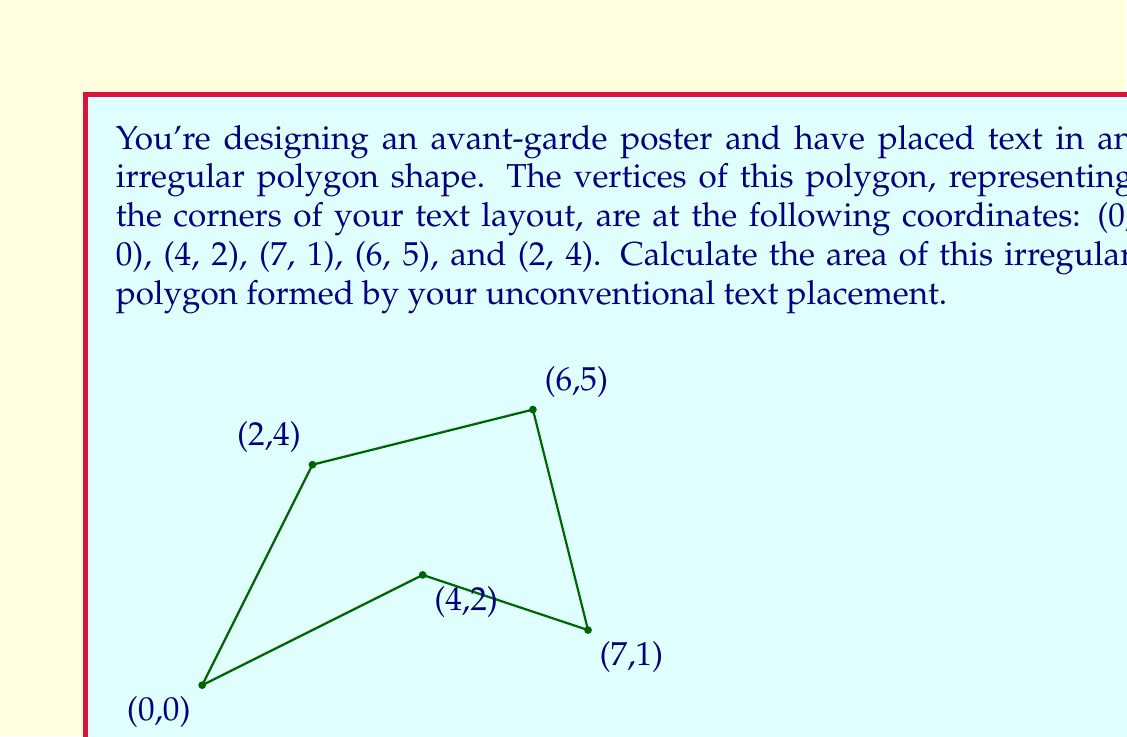What is the answer to this math problem? To solve this problem, we'll use the Shoelace formula (also known as the surveyor's formula) to calculate the area of the irregular polygon. The formula is:

$$ A = \frac{1}{2}|(x_1y_2 + x_2y_3 + ... + x_ny_1) - (y_1x_2 + y_2x_3 + ... + y_nx_1)| $$

Where $(x_i, y_i)$ are the coordinates of the vertices.

Let's apply the formula to our polygon:

1) First, let's list our coordinates in order:
   $(x_1, y_1) = (0, 0)$
   $(x_2, y_2) = (4, 2)$
   $(x_3, y_3) = (7, 1)$
   $(x_4, y_4) = (6, 5)$
   $(x_5, y_5) = (2, 4)$

2) Now, let's calculate the first part of the formula:
   $x_1y_2 + x_2y_3 + x_3y_4 + x_4y_5 + x_5y_1$
   $= (0 \cdot 2) + (4 \cdot 1) + (7 \cdot 5) + (6 \cdot 4) + (2 \cdot 0)$
   $= 0 + 4 + 35 + 24 + 0 = 63$

3) Next, let's calculate the second part:
   $y_1x_2 + y_2x_3 + y_3x_4 + y_4x_5 + y_5x_1$
   $= (0 \cdot 4) + (2 \cdot 7) + (1 \cdot 6) + (5 \cdot 2) + (4 \cdot 0)$
   $= 0 + 14 + 6 + 10 + 0 = 30$

4) Now, we subtract the second part from the first and take the absolute value:
   $|63 - 30| = 33$

5) Finally, we divide by 2:
   $\frac{33}{2} = 16.5$

Therefore, the area of the irregular polygon is 16.5 square units.
Answer: $16.5$ square units 